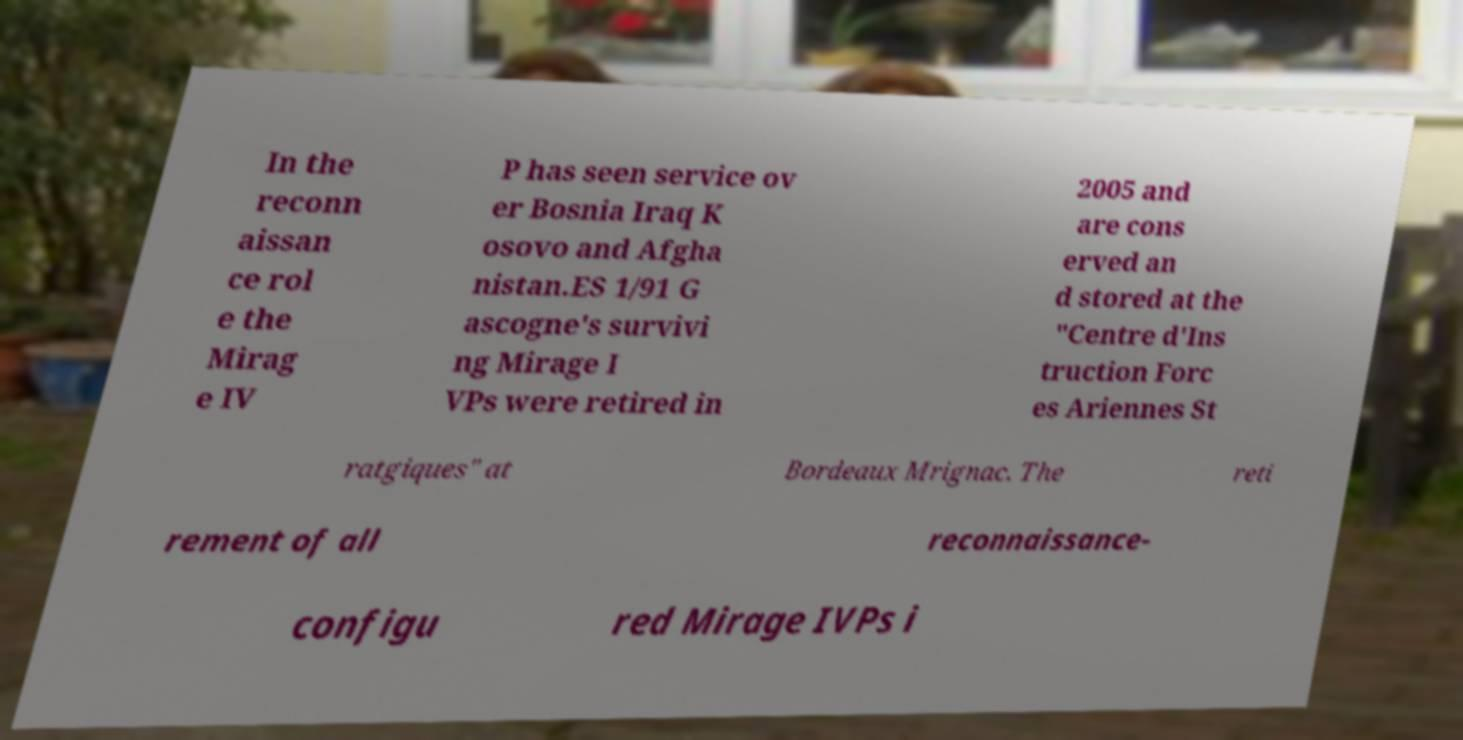Please identify and transcribe the text found in this image. In the reconn aissan ce rol e the Mirag e IV P has seen service ov er Bosnia Iraq K osovo and Afgha nistan.ES 1/91 G ascogne's survivi ng Mirage I VPs were retired in 2005 and are cons erved an d stored at the "Centre d'Ins truction Forc es Ariennes St ratgiques" at Bordeaux Mrignac. The reti rement of all reconnaissance- configu red Mirage IVPs i 